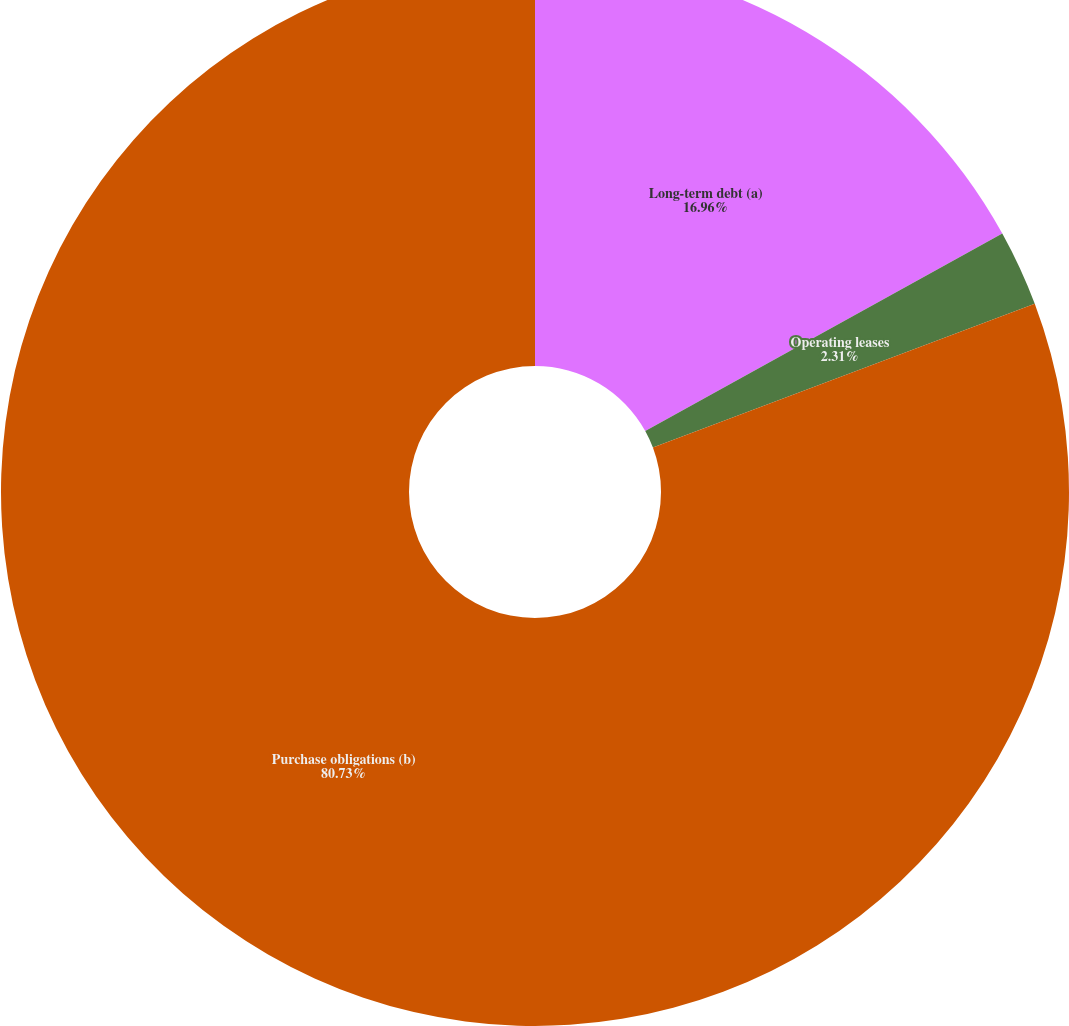<chart> <loc_0><loc_0><loc_500><loc_500><pie_chart><fcel>Long-term debt (a)<fcel>Operating leases<fcel>Purchase obligations (b)<nl><fcel>16.96%<fcel>2.31%<fcel>80.73%<nl></chart> 